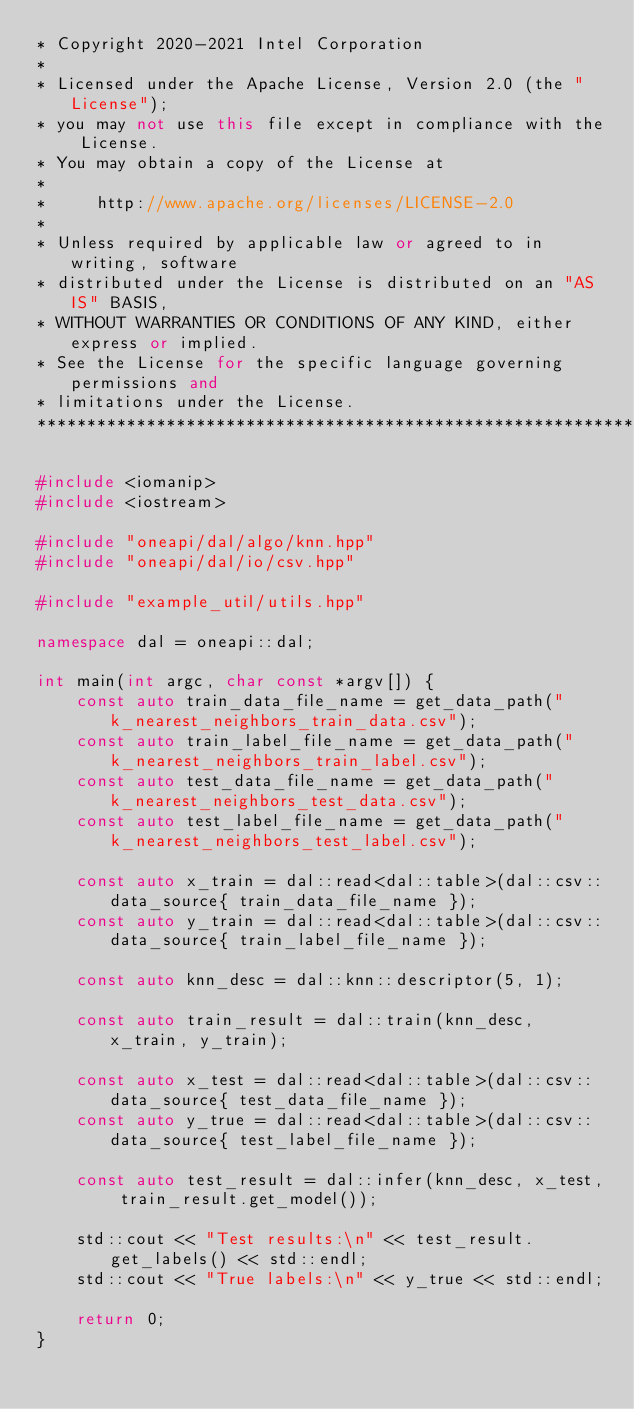<code> <loc_0><loc_0><loc_500><loc_500><_C++_>* Copyright 2020-2021 Intel Corporation
*
* Licensed under the Apache License, Version 2.0 (the "License");
* you may not use this file except in compliance with the License.
* You may obtain a copy of the License at
*
*     http://www.apache.org/licenses/LICENSE-2.0
*
* Unless required by applicable law or agreed to in writing, software
* distributed under the License is distributed on an "AS IS" BASIS,
* WITHOUT WARRANTIES OR CONDITIONS OF ANY KIND, either express or implied.
* See the License for the specific language governing permissions and
* limitations under the License.
*******************************************************************************/

#include <iomanip>
#include <iostream>

#include "oneapi/dal/algo/knn.hpp"
#include "oneapi/dal/io/csv.hpp"

#include "example_util/utils.hpp"

namespace dal = oneapi::dal;

int main(int argc, char const *argv[]) {
    const auto train_data_file_name = get_data_path("k_nearest_neighbors_train_data.csv");
    const auto train_label_file_name = get_data_path("k_nearest_neighbors_train_label.csv");
    const auto test_data_file_name = get_data_path("k_nearest_neighbors_test_data.csv");
    const auto test_label_file_name = get_data_path("k_nearest_neighbors_test_label.csv");

    const auto x_train = dal::read<dal::table>(dal::csv::data_source{ train_data_file_name });
    const auto y_train = dal::read<dal::table>(dal::csv::data_source{ train_label_file_name });

    const auto knn_desc = dal::knn::descriptor(5, 1);

    const auto train_result = dal::train(knn_desc, x_train, y_train);

    const auto x_test = dal::read<dal::table>(dal::csv::data_source{ test_data_file_name });
    const auto y_true = dal::read<dal::table>(dal::csv::data_source{ test_label_file_name });

    const auto test_result = dal::infer(knn_desc, x_test, train_result.get_model());

    std::cout << "Test results:\n" << test_result.get_labels() << std::endl;
    std::cout << "True labels:\n" << y_true << std::endl;

    return 0;
}
</code> 